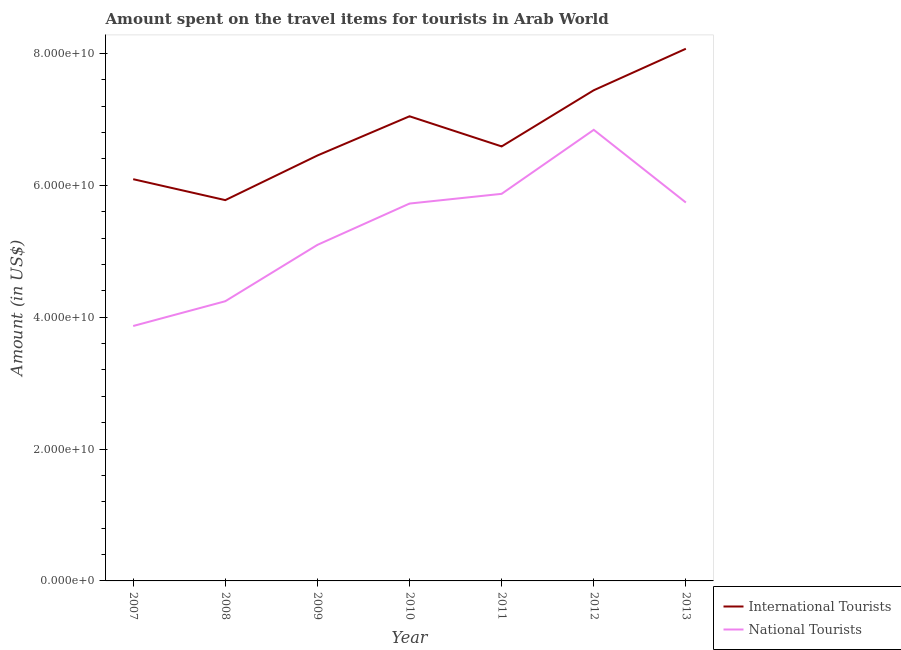What is the amount spent on travel items of national tourists in 2012?
Make the answer very short. 6.84e+1. Across all years, what is the maximum amount spent on travel items of national tourists?
Provide a short and direct response. 6.84e+1. Across all years, what is the minimum amount spent on travel items of national tourists?
Give a very brief answer. 3.87e+1. In which year was the amount spent on travel items of international tourists maximum?
Your answer should be very brief. 2013. In which year was the amount spent on travel items of international tourists minimum?
Keep it short and to the point. 2008. What is the total amount spent on travel items of international tourists in the graph?
Keep it short and to the point. 4.75e+11. What is the difference between the amount spent on travel items of international tourists in 2008 and that in 2010?
Ensure brevity in your answer.  -1.27e+1. What is the difference between the amount spent on travel items of national tourists in 2012 and the amount spent on travel items of international tourists in 2011?
Your answer should be compact. 2.52e+09. What is the average amount spent on travel items of international tourists per year?
Offer a terse response. 6.78e+1. In the year 2010, what is the difference between the amount spent on travel items of international tourists and amount spent on travel items of national tourists?
Offer a very short reply. 1.32e+1. What is the ratio of the amount spent on travel items of international tourists in 2010 to that in 2011?
Keep it short and to the point. 1.07. What is the difference between the highest and the second highest amount spent on travel items of national tourists?
Give a very brief answer. 9.71e+09. What is the difference between the highest and the lowest amount spent on travel items of national tourists?
Ensure brevity in your answer.  2.98e+1. Does the amount spent on travel items of national tourists monotonically increase over the years?
Your answer should be very brief. No. Is the amount spent on travel items of national tourists strictly greater than the amount spent on travel items of international tourists over the years?
Offer a very short reply. No. How many lines are there?
Offer a very short reply. 2. How many years are there in the graph?
Provide a succinct answer. 7. What is the difference between two consecutive major ticks on the Y-axis?
Give a very brief answer. 2.00e+1. Does the graph contain any zero values?
Your response must be concise. No. Does the graph contain grids?
Provide a succinct answer. No. How are the legend labels stacked?
Keep it short and to the point. Vertical. What is the title of the graph?
Ensure brevity in your answer.  Amount spent on the travel items for tourists in Arab World. Does "ODA received" appear as one of the legend labels in the graph?
Your response must be concise. No. What is the label or title of the Y-axis?
Your answer should be very brief. Amount (in US$). What is the Amount (in US$) in International Tourists in 2007?
Ensure brevity in your answer.  6.09e+1. What is the Amount (in US$) of National Tourists in 2007?
Your answer should be very brief. 3.87e+1. What is the Amount (in US$) of International Tourists in 2008?
Your response must be concise. 5.78e+1. What is the Amount (in US$) of National Tourists in 2008?
Provide a succinct answer. 4.24e+1. What is the Amount (in US$) in International Tourists in 2009?
Provide a short and direct response. 6.45e+1. What is the Amount (in US$) in National Tourists in 2009?
Make the answer very short. 5.10e+1. What is the Amount (in US$) of International Tourists in 2010?
Give a very brief answer. 7.05e+1. What is the Amount (in US$) in National Tourists in 2010?
Ensure brevity in your answer.  5.72e+1. What is the Amount (in US$) in International Tourists in 2011?
Provide a succinct answer. 6.59e+1. What is the Amount (in US$) in National Tourists in 2011?
Make the answer very short. 5.87e+1. What is the Amount (in US$) in International Tourists in 2012?
Offer a very short reply. 7.44e+1. What is the Amount (in US$) of National Tourists in 2012?
Your response must be concise. 6.84e+1. What is the Amount (in US$) of International Tourists in 2013?
Your answer should be very brief. 8.07e+1. What is the Amount (in US$) of National Tourists in 2013?
Your response must be concise. 5.74e+1. Across all years, what is the maximum Amount (in US$) in International Tourists?
Ensure brevity in your answer.  8.07e+1. Across all years, what is the maximum Amount (in US$) of National Tourists?
Ensure brevity in your answer.  6.84e+1. Across all years, what is the minimum Amount (in US$) in International Tourists?
Offer a very short reply. 5.78e+1. Across all years, what is the minimum Amount (in US$) of National Tourists?
Your response must be concise. 3.87e+1. What is the total Amount (in US$) in International Tourists in the graph?
Your answer should be compact. 4.75e+11. What is the total Amount (in US$) of National Tourists in the graph?
Your answer should be very brief. 3.74e+11. What is the difference between the Amount (in US$) in International Tourists in 2007 and that in 2008?
Make the answer very short. 3.17e+09. What is the difference between the Amount (in US$) of National Tourists in 2007 and that in 2008?
Make the answer very short. -3.76e+09. What is the difference between the Amount (in US$) of International Tourists in 2007 and that in 2009?
Keep it short and to the point. -3.59e+09. What is the difference between the Amount (in US$) in National Tourists in 2007 and that in 2009?
Keep it short and to the point. -1.23e+1. What is the difference between the Amount (in US$) of International Tourists in 2007 and that in 2010?
Give a very brief answer. -9.54e+09. What is the difference between the Amount (in US$) in National Tourists in 2007 and that in 2010?
Make the answer very short. -1.86e+1. What is the difference between the Amount (in US$) of International Tourists in 2007 and that in 2011?
Give a very brief answer. -4.97e+09. What is the difference between the Amount (in US$) in National Tourists in 2007 and that in 2011?
Give a very brief answer. -2.00e+1. What is the difference between the Amount (in US$) in International Tourists in 2007 and that in 2012?
Your answer should be compact. -1.35e+1. What is the difference between the Amount (in US$) in National Tourists in 2007 and that in 2012?
Keep it short and to the point. -2.98e+1. What is the difference between the Amount (in US$) of International Tourists in 2007 and that in 2013?
Provide a succinct answer. -1.98e+1. What is the difference between the Amount (in US$) of National Tourists in 2007 and that in 2013?
Provide a short and direct response. -1.87e+1. What is the difference between the Amount (in US$) in International Tourists in 2008 and that in 2009?
Provide a succinct answer. -6.77e+09. What is the difference between the Amount (in US$) of National Tourists in 2008 and that in 2009?
Provide a succinct answer. -8.55e+09. What is the difference between the Amount (in US$) in International Tourists in 2008 and that in 2010?
Your response must be concise. -1.27e+1. What is the difference between the Amount (in US$) of National Tourists in 2008 and that in 2010?
Provide a short and direct response. -1.48e+1. What is the difference between the Amount (in US$) in International Tourists in 2008 and that in 2011?
Offer a terse response. -8.14e+09. What is the difference between the Amount (in US$) in National Tourists in 2008 and that in 2011?
Your answer should be compact. -1.63e+1. What is the difference between the Amount (in US$) of International Tourists in 2008 and that in 2012?
Provide a succinct answer. -1.67e+1. What is the difference between the Amount (in US$) of National Tourists in 2008 and that in 2012?
Offer a very short reply. -2.60e+1. What is the difference between the Amount (in US$) in International Tourists in 2008 and that in 2013?
Ensure brevity in your answer.  -2.30e+1. What is the difference between the Amount (in US$) of National Tourists in 2008 and that in 2013?
Your response must be concise. -1.50e+1. What is the difference between the Amount (in US$) of International Tourists in 2009 and that in 2010?
Provide a succinct answer. -5.95e+09. What is the difference between the Amount (in US$) in National Tourists in 2009 and that in 2010?
Provide a short and direct response. -6.27e+09. What is the difference between the Amount (in US$) of International Tourists in 2009 and that in 2011?
Keep it short and to the point. -1.38e+09. What is the difference between the Amount (in US$) of National Tourists in 2009 and that in 2011?
Keep it short and to the point. -7.74e+09. What is the difference between the Amount (in US$) of International Tourists in 2009 and that in 2012?
Provide a short and direct response. -9.90e+09. What is the difference between the Amount (in US$) of National Tourists in 2009 and that in 2012?
Offer a terse response. -1.74e+1. What is the difference between the Amount (in US$) in International Tourists in 2009 and that in 2013?
Your answer should be very brief. -1.62e+1. What is the difference between the Amount (in US$) in National Tourists in 2009 and that in 2013?
Your answer should be very brief. -6.42e+09. What is the difference between the Amount (in US$) of International Tourists in 2010 and that in 2011?
Give a very brief answer. 4.57e+09. What is the difference between the Amount (in US$) of National Tourists in 2010 and that in 2011?
Provide a succinct answer. -1.47e+09. What is the difference between the Amount (in US$) in International Tourists in 2010 and that in 2012?
Your answer should be very brief. -3.95e+09. What is the difference between the Amount (in US$) in National Tourists in 2010 and that in 2012?
Give a very brief answer. -1.12e+1. What is the difference between the Amount (in US$) in International Tourists in 2010 and that in 2013?
Keep it short and to the point. -1.02e+1. What is the difference between the Amount (in US$) in National Tourists in 2010 and that in 2013?
Ensure brevity in your answer.  -1.57e+08. What is the difference between the Amount (in US$) in International Tourists in 2011 and that in 2012?
Provide a succinct answer. -8.52e+09. What is the difference between the Amount (in US$) in National Tourists in 2011 and that in 2012?
Your answer should be very brief. -9.71e+09. What is the difference between the Amount (in US$) in International Tourists in 2011 and that in 2013?
Your answer should be compact. -1.48e+1. What is the difference between the Amount (in US$) in National Tourists in 2011 and that in 2013?
Your answer should be very brief. 1.32e+09. What is the difference between the Amount (in US$) in International Tourists in 2012 and that in 2013?
Keep it short and to the point. -6.30e+09. What is the difference between the Amount (in US$) in National Tourists in 2012 and that in 2013?
Provide a succinct answer. 1.10e+1. What is the difference between the Amount (in US$) of International Tourists in 2007 and the Amount (in US$) of National Tourists in 2008?
Ensure brevity in your answer.  1.85e+1. What is the difference between the Amount (in US$) of International Tourists in 2007 and the Amount (in US$) of National Tourists in 2009?
Your answer should be compact. 9.96e+09. What is the difference between the Amount (in US$) of International Tourists in 2007 and the Amount (in US$) of National Tourists in 2010?
Provide a short and direct response. 3.70e+09. What is the difference between the Amount (in US$) of International Tourists in 2007 and the Amount (in US$) of National Tourists in 2011?
Provide a short and direct response. 2.22e+09. What is the difference between the Amount (in US$) in International Tourists in 2007 and the Amount (in US$) in National Tourists in 2012?
Ensure brevity in your answer.  -7.49e+09. What is the difference between the Amount (in US$) of International Tourists in 2007 and the Amount (in US$) of National Tourists in 2013?
Provide a succinct answer. 3.54e+09. What is the difference between the Amount (in US$) of International Tourists in 2008 and the Amount (in US$) of National Tourists in 2009?
Ensure brevity in your answer.  6.79e+09. What is the difference between the Amount (in US$) of International Tourists in 2008 and the Amount (in US$) of National Tourists in 2010?
Keep it short and to the point. 5.22e+08. What is the difference between the Amount (in US$) of International Tourists in 2008 and the Amount (in US$) of National Tourists in 2011?
Offer a very short reply. -9.53e+08. What is the difference between the Amount (in US$) of International Tourists in 2008 and the Amount (in US$) of National Tourists in 2012?
Keep it short and to the point. -1.07e+1. What is the difference between the Amount (in US$) of International Tourists in 2008 and the Amount (in US$) of National Tourists in 2013?
Your answer should be very brief. 3.65e+08. What is the difference between the Amount (in US$) of International Tourists in 2009 and the Amount (in US$) of National Tourists in 2010?
Ensure brevity in your answer.  7.29e+09. What is the difference between the Amount (in US$) of International Tourists in 2009 and the Amount (in US$) of National Tourists in 2011?
Make the answer very short. 5.81e+09. What is the difference between the Amount (in US$) in International Tourists in 2009 and the Amount (in US$) in National Tourists in 2012?
Provide a succinct answer. -3.89e+09. What is the difference between the Amount (in US$) in International Tourists in 2009 and the Amount (in US$) in National Tourists in 2013?
Provide a succinct answer. 7.13e+09. What is the difference between the Amount (in US$) of International Tourists in 2010 and the Amount (in US$) of National Tourists in 2011?
Keep it short and to the point. 1.18e+1. What is the difference between the Amount (in US$) in International Tourists in 2010 and the Amount (in US$) in National Tourists in 2012?
Your answer should be compact. 2.06e+09. What is the difference between the Amount (in US$) of International Tourists in 2010 and the Amount (in US$) of National Tourists in 2013?
Provide a succinct answer. 1.31e+1. What is the difference between the Amount (in US$) in International Tourists in 2011 and the Amount (in US$) in National Tourists in 2012?
Offer a terse response. -2.52e+09. What is the difference between the Amount (in US$) in International Tourists in 2011 and the Amount (in US$) in National Tourists in 2013?
Offer a terse response. 8.51e+09. What is the difference between the Amount (in US$) in International Tourists in 2012 and the Amount (in US$) in National Tourists in 2013?
Your answer should be compact. 1.70e+1. What is the average Amount (in US$) in International Tourists per year?
Give a very brief answer. 6.78e+1. What is the average Amount (in US$) in National Tourists per year?
Offer a very short reply. 5.34e+1. In the year 2007, what is the difference between the Amount (in US$) of International Tourists and Amount (in US$) of National Tourists?
Ensure brevity in your answer.  2.23e+1. In the year 2008, what is the difference between the Amount (in US$) of International Tourists and Amount (in US$) of National Tourists?
Offer a very short reply. 1.53e+1. In the year 2009, what is the difference between the Amount (in US$) of International Tourists and Amount (in US$) of National Tourists?
Your response must be concise. 1.36e+1. In the year 2010, what is the difference between the Amount (in US$) of International Tourists and Amount (in US$) of National Tourists?
Offer a terse response. 1.32e+1. In the year 2011, what is the difference between the Amount (in US$) of International Tourists and Amount (in US$) of National Tourists?
Provide a short and direct response. 7.19e+09. In the year 2012, what is the difference between the Amount (in US$) in International Tourists and Amount (in US$) in National Tourists?
Provide a succinct answer. 6.00e+09. In the year 2013, what is the difference between the Amount (in US$) of International Tourists and Amount (in US$) of National Tourists?
Keep it short and to the point. 2.33e+1. What is the ratio of the Amount (in US$) of International Tourists in 2007 to that in 2008?
Give a very brief answer. 1.05. What is the ratio of the Amount (in US$) in National Tourists in 2007 to that in 2008?
Your answer should be compact. 0.91. What is the ratio of the Amount (in US$) in International Tourists in 2007 to that in 2009?
Provide a succinct answer. 0.94. What is the ratio of the Amount (in US$) in National Tourists in 2007 to that in 2009?
Offer a very short reply. 0.76. What is the ratio of the Amount (in US$) of International Tourists in 2007 to that in 2010?
Provide a succinct answer. 0.86. What is the ratio of the Amount (in US$) of National Tourists in 2007 to that in 2010?
Your answer should be compact. 0.68. What is the ratio of the Amount (in US$) in International Tourists in 2007 to that in 2011?
Provide a short and direct response. 0.92. What is the ratio of the Amount (in US$) in National Tourists in 2007 to that in 2011?
Give a very brief answer. 0.66. What is the ratio of the Amount (in US$) of International Tourists in 2007 to that in 2012?
Your answer should be compact. 0.82. What is the ratio of the Amount (in US$) of National Tourists in 2007 to that in 2012?
Give a very brief answer. 0.57. What is the ratio of the Amount (in US$) in International Tourists in 2007 to that in 2013?
Make the answer very short. 0.75. What is the ratio of the Amount (in US$) of National Tourists in 2007 to that in 2013?
Offer a very short reply. 0.67. What is the ratio of the Amount (in US$) of International Tourists in 2008 to that in 2009?
Make the answer very short. 0.9. What is the ratio of the Amount (in US$) in National Tourists in 2008 to that in 2009?
Your response must be concise. 0.83. What is the ratio of the Amount (in US$) in International Tourists in 2008 to that in 2010?
Make the answer very short. 0.82. What is the ratio of the Amount (in US$) in National Tourists in 2008 to that in 2010?
Your response must be concise. 0.74. What is the ratio of the Amount (in US$) in International Tourists in 2008 to that in 2011?
Provide a succinct answer. 0.88. What is the ratio of the Amount (in US$) in National Tourists in 2008 to that in 2011?
Offer a very short reply. 0.72. What is the ratio of the Amount (in US$) of International Tourists in 2008 to that in 2012?
Offer a very short reply. 0.78. What is the ratio of the Amount (in US$) in National Tourists in 2008 to that in 2012?
Offer a terse response. 0.62. What is the ratio of the Amount (in US$) in International Tourists in 2008 to that in 2013?
Provide a succinct answer. 0.72. What is the ratio of the Amount (in US$) in National Tourists in 2008 to that in 2013?
Keep it short and to the point. 0.74. What is the ratio of the Amount (in US$) in International Tourists in 2009 to that in 2010?
Make the answer very short. 0.92. What is the ratio of the Amount (in US$) of National Tourists in 2009 to that in 2010?
Provide a short and direct response. 0.89. What is the ratio of the Amount (in US$) in International Tourists in 2009 to that in 2011?
Your answer should be very brief. 0.98. What is the ratio of the Amount (in US$) in National Tourists in 2009 to that in 2011?
Keep it short and to the point. 0.87. What is the ratio of the Amount (in US$) in International Tourists in 2009 to that in 2012?
Your response must be concise. 0.87. What is the ratio of the Amount (in US$) of National Tourists in 2009 to that in 2012?
Make the answer very short. 0.74. What is the ratio of the Amount (in US$) in International Tourists in 2009 to that in 2013?
Your answer should be very brief. 0.8. What is the ratio of the Amount (in US$) in National Tourists in 2009 to that in 2013?
Keep it short and to the point. 0.89. What is the ratio of the Amount (in US$) of International Tourists in 2010 to that in 2011?
Make the answer very short. 1.07. What is the ratio of the Amount (in US$) of National Tourists in 2010 to that in 2011?
Provide a succinct answer. 0.97. What is the ratio of the Amount (in US$) of International Tourists in 2010 to that in 2012?
Your answer should be very brief. 0.95. What is the ratio of the Amount (in US$) of National Tourists in 2010 to that in 2012?
Your response must be concise. 0.84. What is the ratio of the Amount (in US$) in International Tourists in 2010 to that in 2013?
Your response must be concise. 0.87. What is the ratio of the Amount (in US$) in International Tourists in 2011 to that in 2012?
Offer a very short reply. 0.89. What is the ratio of the Amount (in US$) of National Tourists in 2011 to that in 2012?
Offer a very short reply. 0.86. What is the ratio of the Amount (in US$) in International Tourists in 2011 to that in 2013?
Provide a short and direct response. 0.82. What is the ratio of the Amount (in US$) of International Tourists in 2012 to that in 2013?
Your answer should be very brief. 0.92. What is the ratio of the Amount (in US$) of National Tourists in 2012 to that in 2013?
Offer a very short reply. 1.19. What is the difference between the highest and the second highest Amount (in US$) in International Tourists?
Your answer should be compact. 6.30e+09. What is the difference between the highest and the second highest Amount (in US$) in National Tourists?
Your answer should be compact. 9.71e+09. What is the difference between the highest and the lowest Amount (in US$) in International Tourists?
Offer a very short reply. 2.30e+1. What is the difference between the highest and the lowest Amount (in US$) in National Tourists?
Provide a short and direct response. 2.98e+1. 